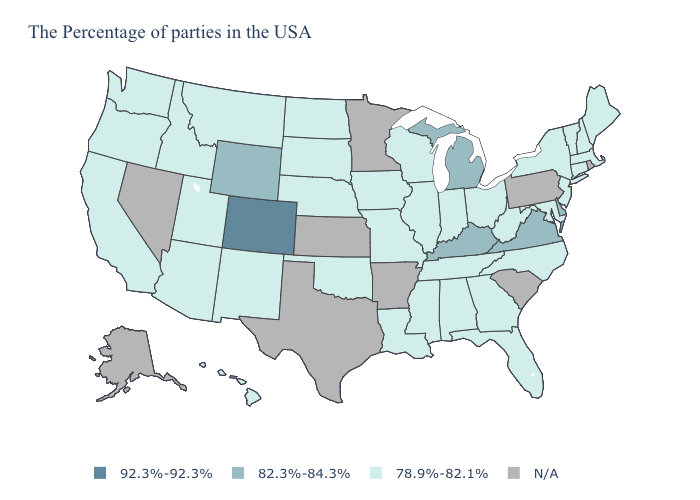Name the states that have a value in the range 92.3%-92.3%?
Be succinct. Colorado. Among the states that border Minnesota , which have the lowest value?
Concise answer only. Wisconsin, Iowa, South Dakota, North Dakota. What is the highest value in states that border New Jersey?
Give a very brief answer. 82.3%-84.3%. What is the value of North Carolina?
Write a very short answer. 78.9%-82.1%. What is the value of Ohio?
Write a very short answer. 78.9%-82.1%. Name the states that have a value in the range 78.9%-82.1%?
Concise answer only. Maine, Massachusetts, New Hampshire, Vermont, Connecticut, New York, New Jersey, Maryland, North Carolina, West Virginia, Ohio, Florida, Georgia, Indiana, Alabama, Tennessee, Wisconsin, Illinois, Mississippi, Louisiana, Missouri, Iowa, Nebraska, Oklahoma, South Dakota, North Dakota, New Mexico, Utah, Montana, Arizona, Idaho, California, Washington, Oregon, Hawaii. Name the states that have a value in the range 82.3%-84.3%?
Write a very short answer. Delaware, Virginia, Michigan, Kentucky, Wyoming. What is the value of Vermont?
Concise answer only. 78.9%-82.1%. What is the value of Delaware?
Short answer required. 82.3%-84.3%. What is the value of West Virginia?
Give a very brief answer. 78.9%-82.1%. What is the value of Idaho?
Give a very brief answer. 78.9%-82.1%. What is the value of Iowa?
Give a very brief answer. 78.9%-82.1%. Name the states that have a value in the range 78.9%-82.1%?
Be succinct. Maine, Massachusetts, New Hampshire, Vermont, Connecticut, New York, New Jersey, Maryland, North Carolina, West Virginia, Ohio, Florida, Georgia, Indiana, Alabama, Tennessee, Wisconsin, Illinois, Mississippi, Louisiana, Missouri, Iowa, Nebraska, Oklahoma, South Dakota, North Dakota, New Mexico, Utah, Montana, Arizona, Idaho, California, Washington, Oregon, Hawaii. 